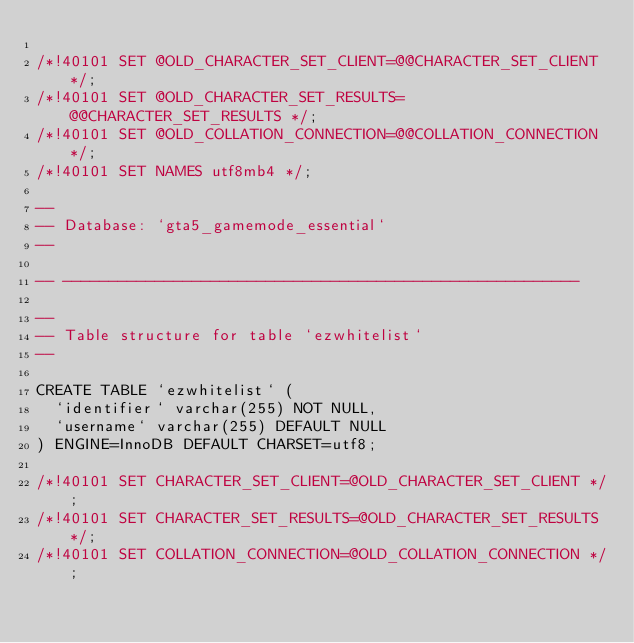Convert code to text. <code><loc_0><loc_0><loc_500><loc_500><_SQL_>
/*!40101 SET @OLD_CHARACTER_SET_CLIENT=@@CHARACTER_SET_CLIENT */;
/*!40101 SET @OLD_CHARACTER_SET_RESULTS=@@CHARACTER_SET_RESULTS */;
/*!40101 SET @OLD_COLLATION_CONNECTION=@@COLLATION_CONNECTION */;
/*!40101 SET NAMES utf8mb4 */;

--
-- Database: `gta5_gamemode_essential`
--

-- --------------------------------------------------------

--
-- Table structure for table `ezwhitelist`
--

CREATE TABLE `ezwhitelist` (
  `identifier` varchar(255) NOT NULL,
  `username` varchar(255) DEFAULT NULL
) ENGINE=InnoDB DEFAULT CHARSET=utf8;

/*!40101 SET CHARACTER_SET_CLIENT=@OLD_CHARACTER_SET_CLIENT */;
/*!40101 SET CHARACTER_SET_RESULTS=@OLD_CHARACTER_SET_RESULTS */;
/*!40101 SET COLLATION_CONNECTION=@OLD_COLLATION_CONNECTION */;
</code> 